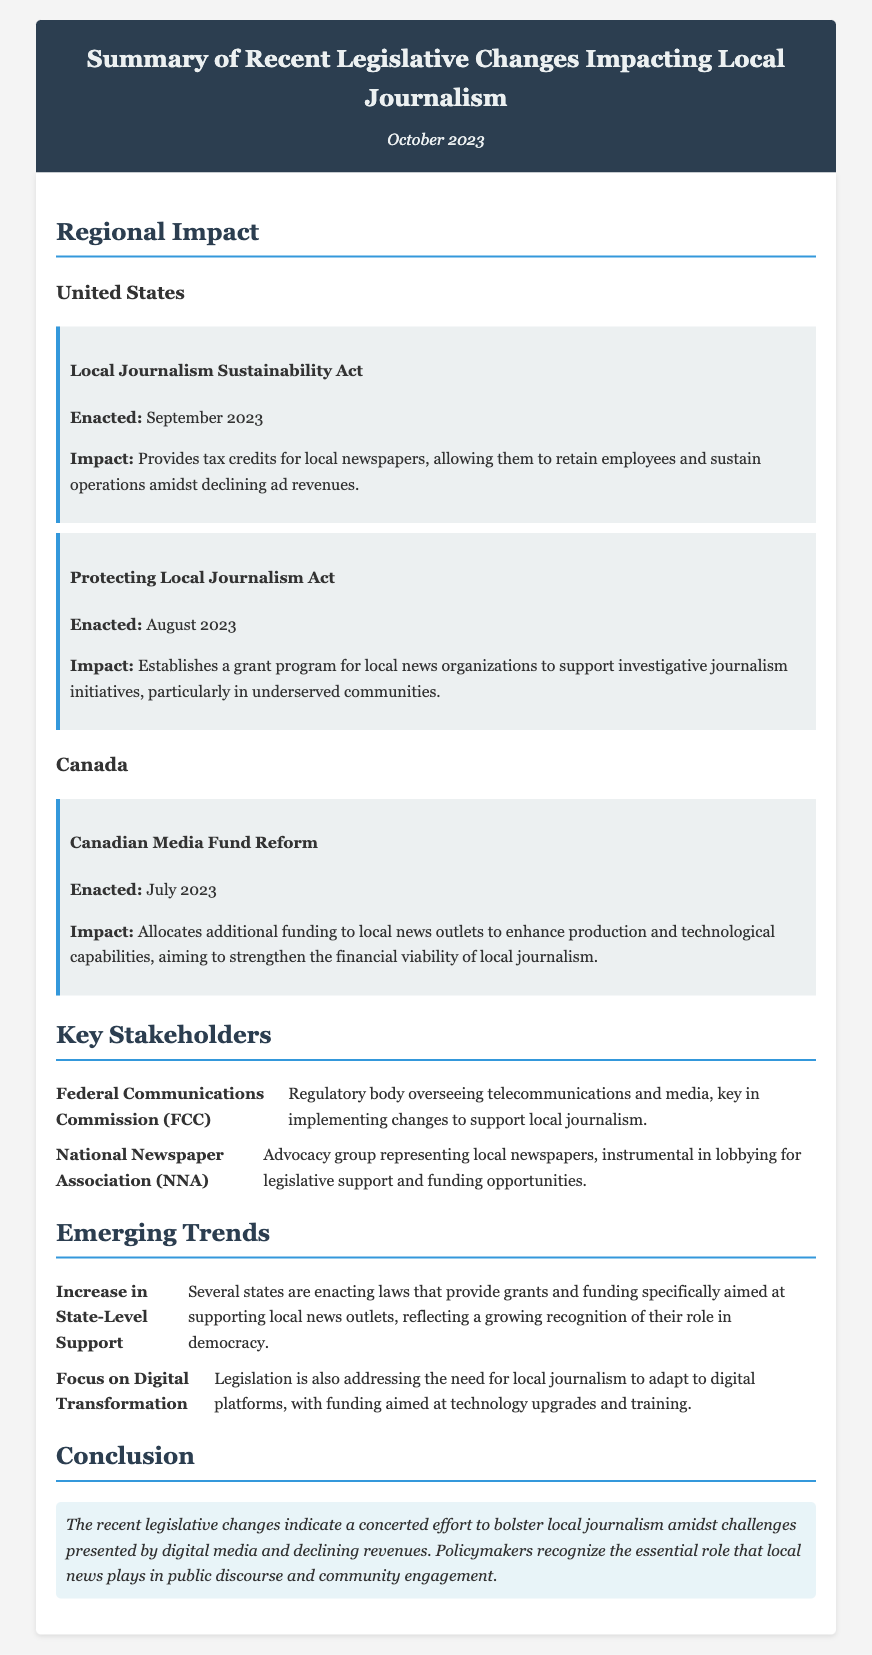What is the title of the document? The title is displayed prominently at the top of the document, stating its focus on legislative changes.
Answer: Summary of Recent Legislative Changes Impacting Local Journalism When was the Local Journalism Sustainability Act enacted? The enactment date is included with the description of the legislative change for easy reference.
Answer: September 2023 What is the primary purpose of the Protecting Local Journalism Act? The document outlines the impact of the act, specifically mentioning its focus on investigative journalism.
Answer: Support investigative journalism initiatives Which country enacted the Canadian Media Fund Reform? The document clearly states the country associated with each legislative change.
Answer: Canada Who oversees telecommunications and media in the United States? The document specifies key stakeholders and their roles within the context of local journalism.
Answer: Federal Communications Commission (FCC) What trend reflects growing state-level support for local news outlets? The document summarizes emerging trends, highlighting increasing state support specific to local journalism.
Answer: Increase in State-Level Support What is a key focus of current legislation regarding local journalism? The document lists trends that indicate legislative focuses, including the adaptation to modern needs.
Answer: Digital Transformation What significant funding initiative supports technology upgrades for local journalism? The document discusses funding aimed at addressing technological needs within the journalism sector.
Answer: Funding aimed at technology upgrades What conclusion is drawn about recent legislative changes? The conclusion section provides a summary statement regarding the intent of legislative changes for local journalism.
Answer: Bolster local journalism 